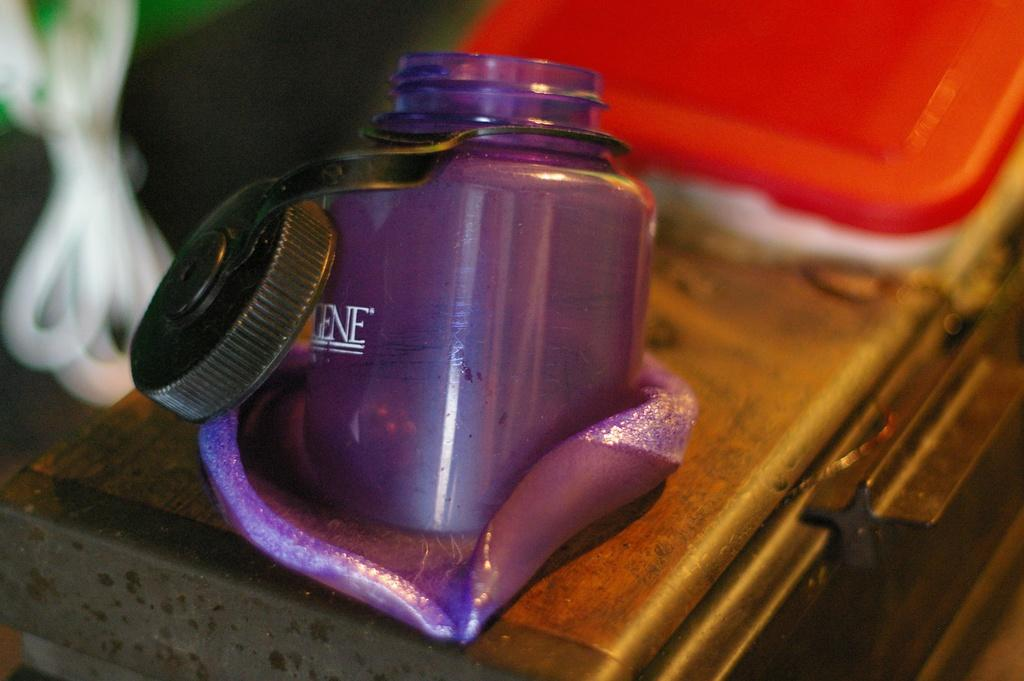What is the person in the image holding? The person is holding a camera. What can be seen in the background of the image? There is a building in the background of the image. What type of fear can be seen on the person's face in the image? There is no indication of fear on the person's face in the image. Can you see a rabbit hiding behind the building in the image? There is no rabbit present in the image. 